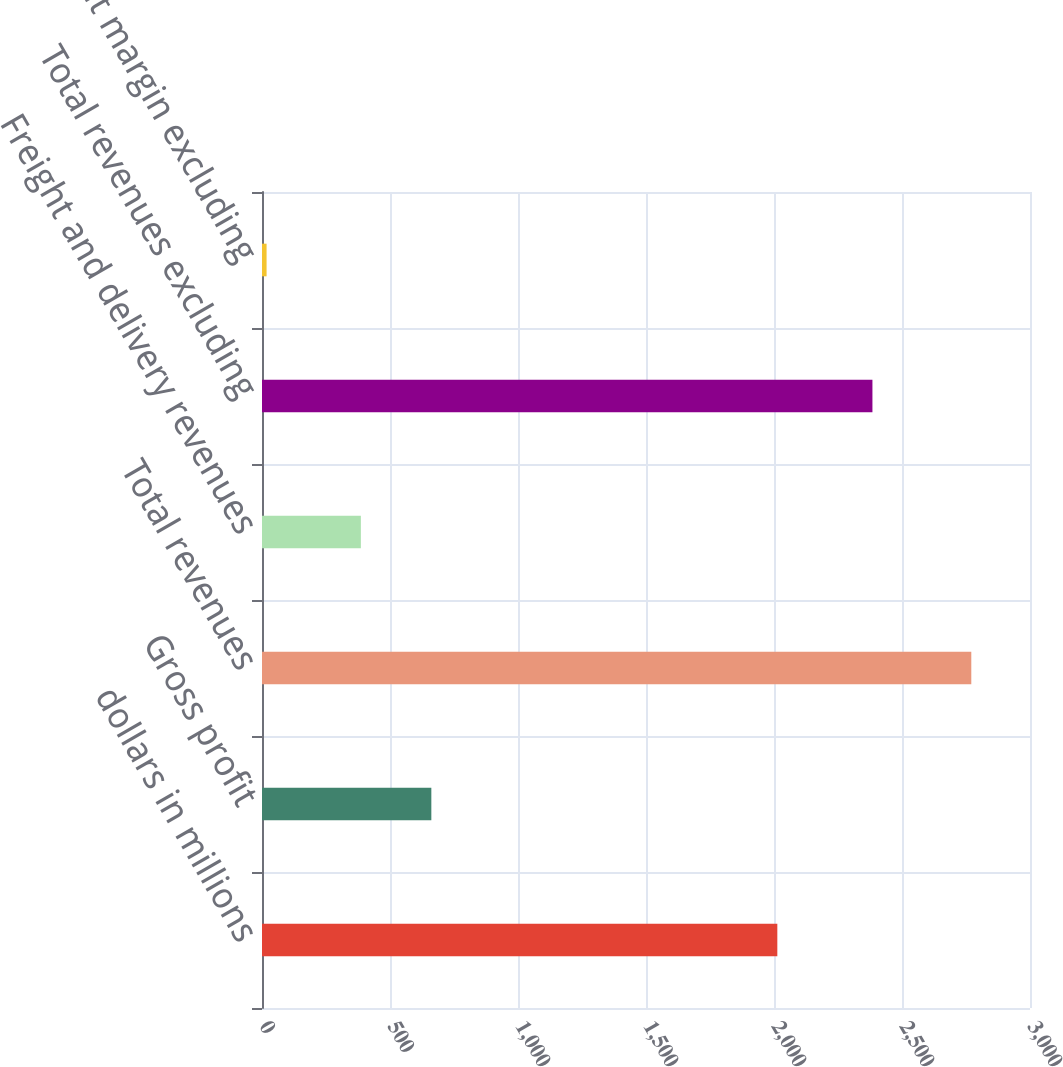<chart> <loc_0><loc_0><loc_500><loc_500><bar_chart><fcel>dollars in millions<fcel>Gross profit<fcel>Total revenues<fcel>Freight and delivery revenues<fcel>Total revenues excluding<fcel>Gross profit margin excluding<nl><fcel>2013<fcel>661.48<fcel>2770.7<fcel>386.2<fcel>2384.5<fcel>17.9<nl></chart> 